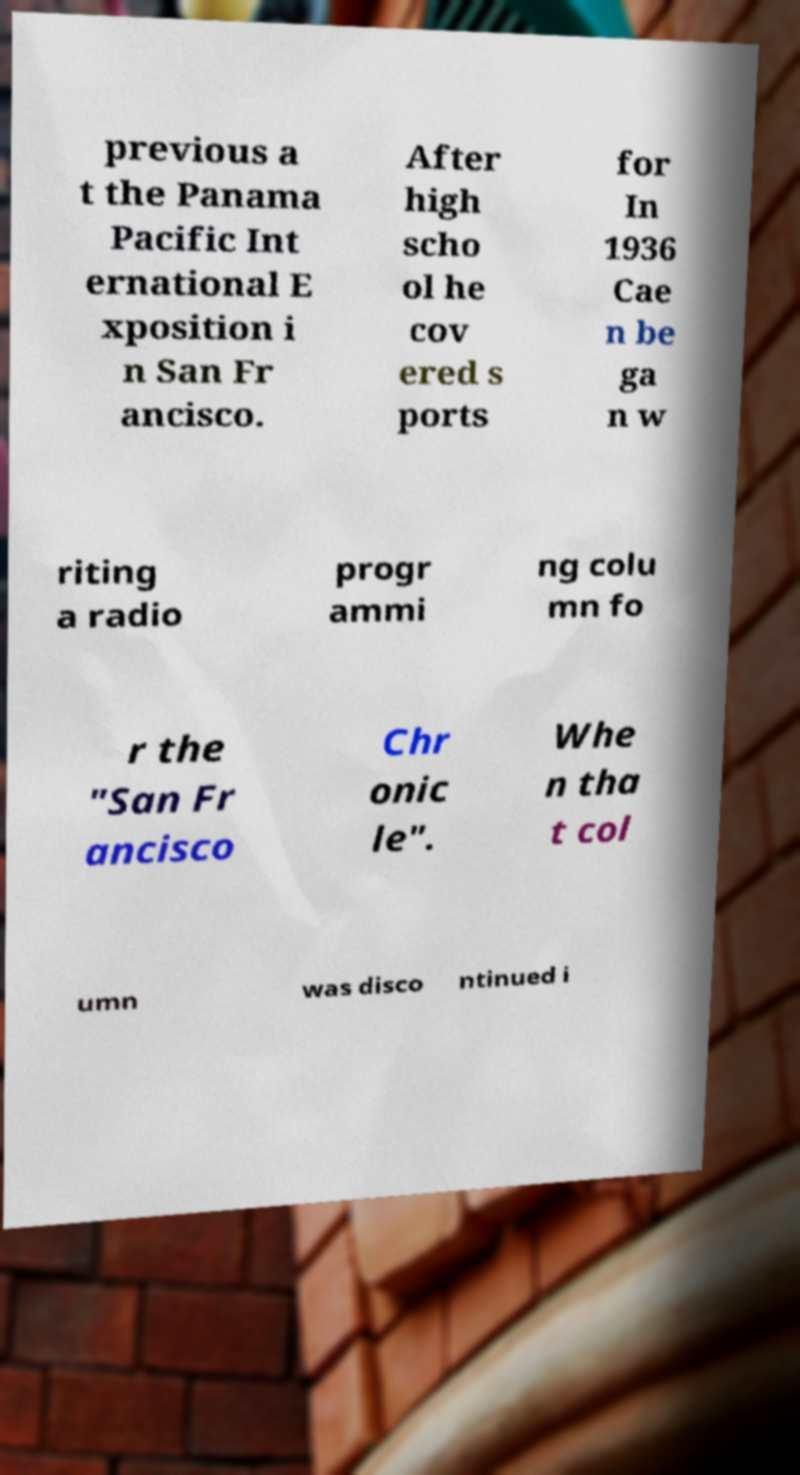For documentation purposes, I need the text within this image transcribed. Could you provide that? previous a t the Panama Pacific Int ernational E xposition i n San Fr ancisco. After high scho ol he cov ered s ports for In 1936 Cae n be ga n w riting a radio progr ammi ng colu mn fo r the "San Fr ancisco Chr onic le". Whe n tha t col umn was disco ntinued i 